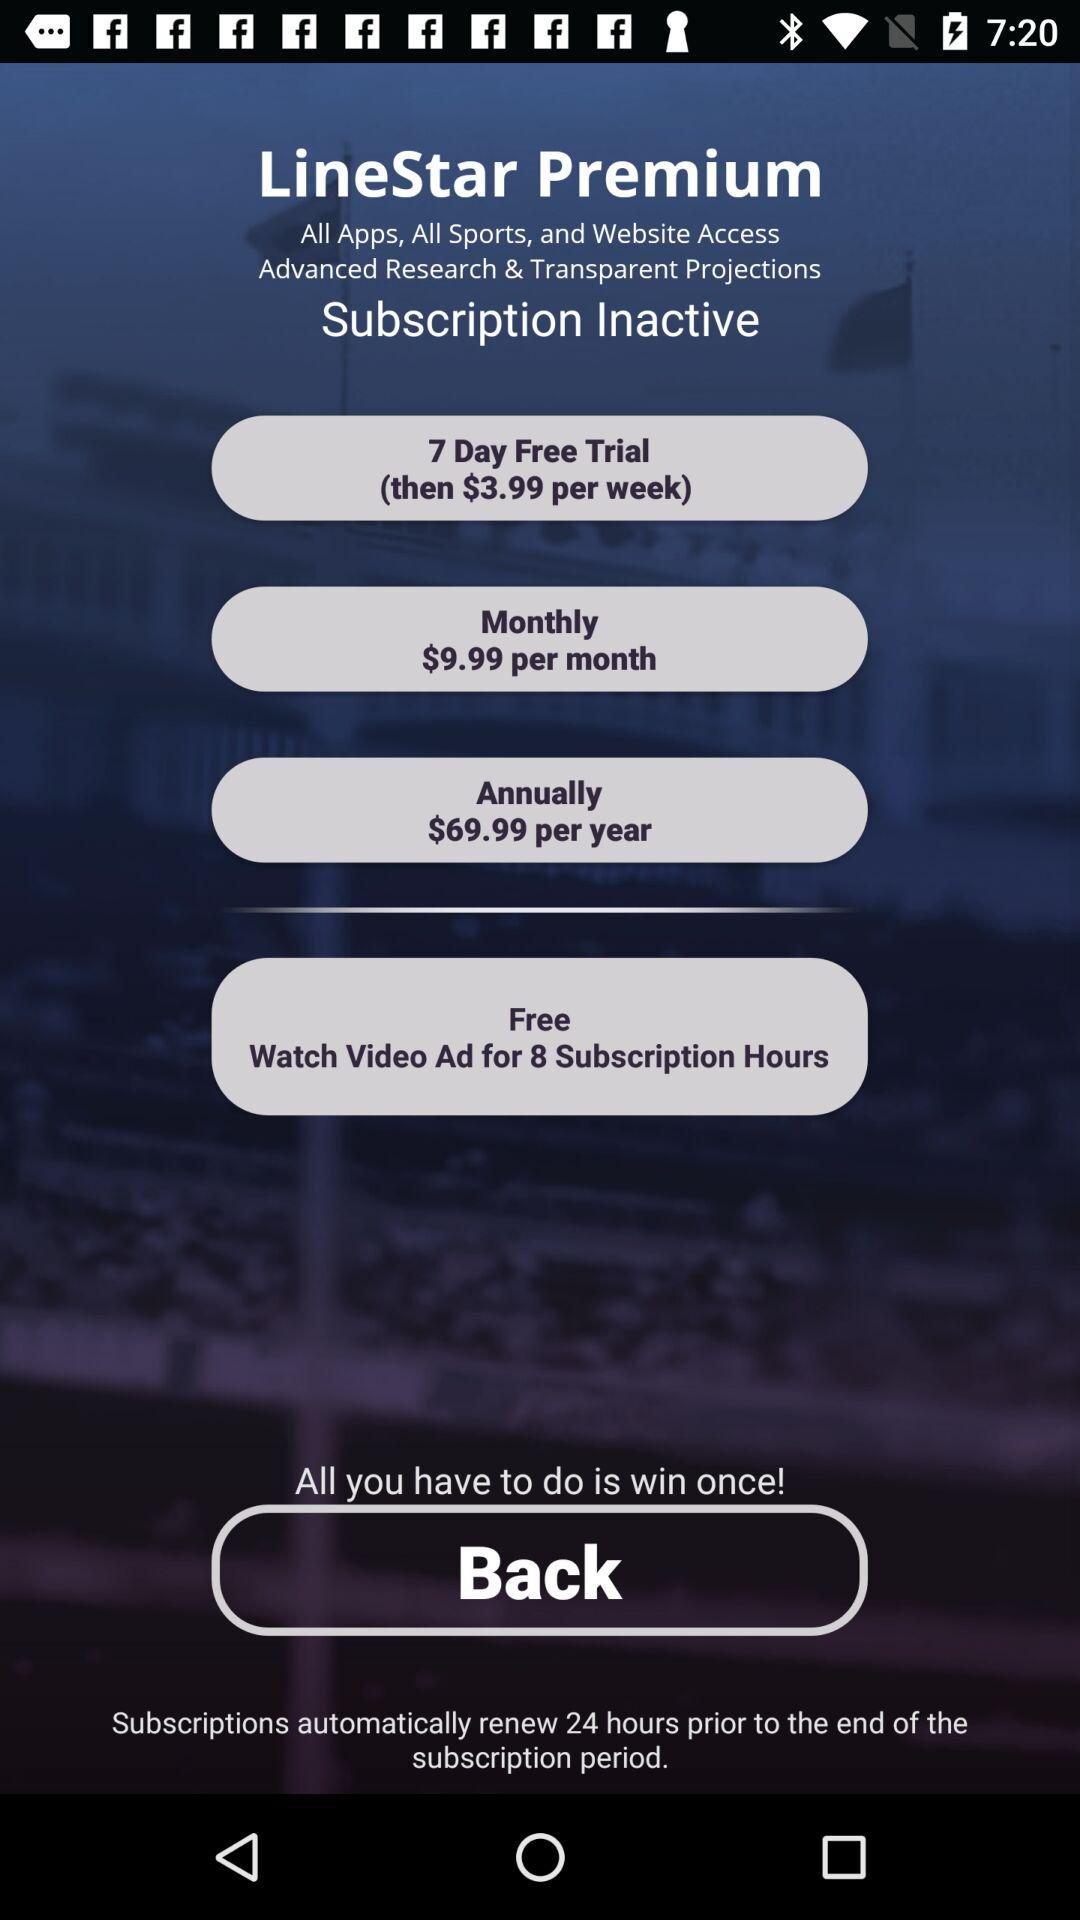What is the cost per week after the free trial? The cost is $3.99 per week. 